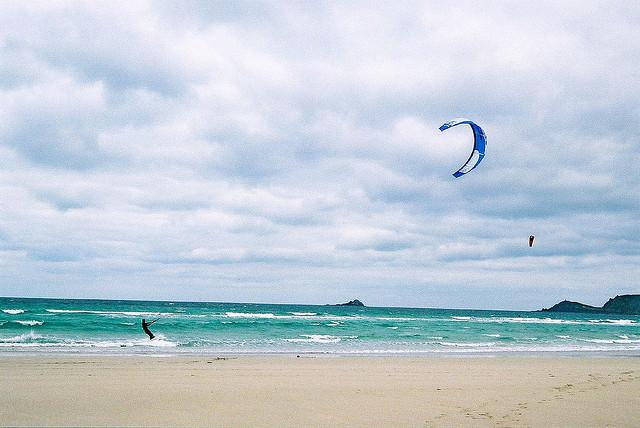What color are the eyes on the edges of the parasail pulling the skier? white 